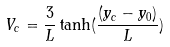Convert formula to latex. <formula><loc_0><loc_0><loc_500><loc_500>V _ { c } = \frac { 3 } { L } \tanh ( \frac { ( y _ { c } - y _ { 0 } ) } { L } )</formula> 